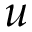Convert formula to latex. <formula><loc_0><loc_0><loc_500><loc_500>u</formula> 